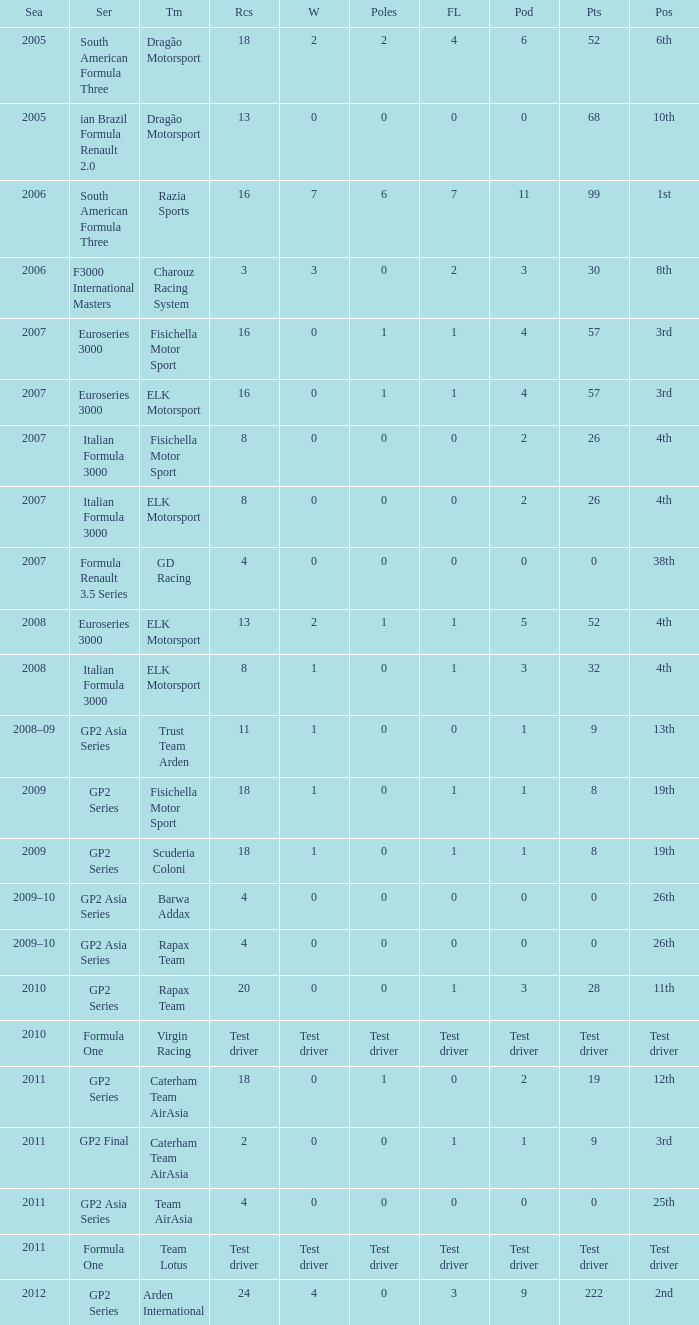When did he end up with 0 poles and a 19th place finish in the gp2 series season? 2009, 2009. 